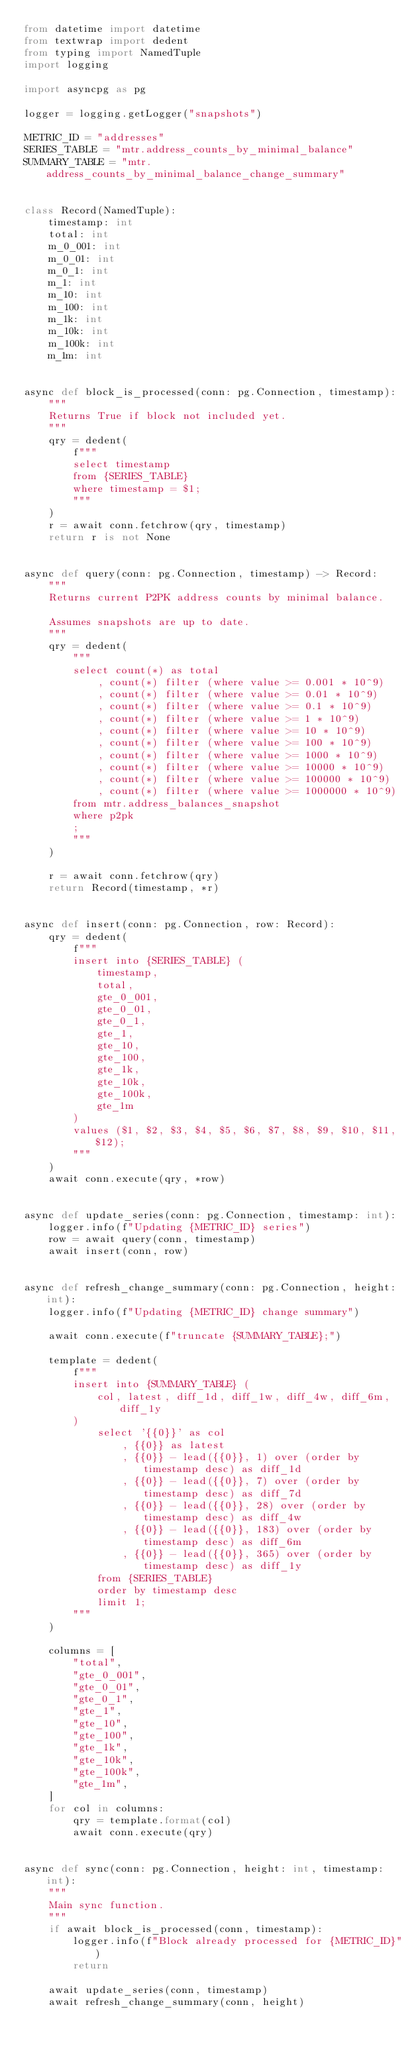Convert code to text. <code><loc_0><loc_0><loc_500><loc_500><_Python_>from datetime import datetime
from textwrap import dedent
from typing import NamedTuple
import logging

import asyncpg as pg

logger = logging.getLogger("snapshots")

METRIC_ID = "addresses"
SERIES_TABLE = "mtr.address_counts_by_minimal_balance"
SUMMARY_TABLE = "mtr.address_counts_by_minimal_balance_change_summary"


class Record(NamedTuple):
    timestamp: int
    total: int
    m_0_001: int
    m_0_01: int
    m_0_1: int
    m_1: int
    m_10: int
    m_100: int
    m_1k: int
    m_10k: int
    m_100k: int
    m_1m: int


async def block_is_processed(conn: pg.Connection, timestamp):
    """
    Returns True if block not included yet.
    """
    qry = dedent(
        f"""
        select timestamp
        from {SERIES_TABLE}
        where timestamp = $1;
        """
    )
    r = await conn.fetchrow(qry, timestamp)
    return r is not None


async def query(conn: pg.Connection, timestamp) -> Record:
    """
    Returns current P2PK address counts by minimal balance.

    Assumes snapshots are up to date.
    """
    qry = dedent(
        """
        select count(*) as total
            , count(*) filter (where value >= 0.001 * 10^9)
            , count(*) filter (where value >= 0.01 * 10^9)
            , count(*) filter (where value >= 0.1 * 10^9)
            , count(*) filter (where value >= 1 * 10^9)
            , count(*) filter (where value >= 10 * 10^9)
            , count(*) filter (where value >= 100 * 10^9)
            , count(*) filter (where value >= 1000 * 10^9)
            , count(*) filter (where value >= 10000 * 10^9)
            , count(*) filter (where value >= 100000 * 10^9)
            , count(*) filter (where value >= 1000000 * 10^9)
        from mtr.address_balances_snapshot
        where p2pk
        ;
        """
    )

    r = await conn.fetchrow(qry)
    return Record(timestamp, *r)


async def insert(conn: pg.Connection, row: Record):
    qry = dedent(
        f"""
        insert into {SERIES_TABLE} (
            timestamp,
            total,
            gte_0_001,
            gte_0_01,
            gte_0_1,
            gte_1,
            gte_10,
            gte_100,
            gte_1k,
            gte_10k,
            gte_100k,
            gte_1m
        )
        values ($1, $2, $3, $4, $5, $6, $7, $8, $9, $10, $11, $12);
        """
    )
    await conn.execute(qry, *row)


async def update_series(conn: pg.Connection, timestamp: int):
    logger.info(f"Updating {METRIC_ID} series")
    row = await query(conn, timestamp)
    await insert(conn, row)


async def refresh_change_summary(conn: pg.Connection, height: int):
    logger.info(f"Updating {METRIC_ID} change summary")

    await conn.execute(f"truncate {SUMMARY_TABLE};")

    template = dedent(
        f"""
        insert into {SUMMARY_TABLE} (
            col, latest, diff_1d, diff_1w, diff_4w, diff_6m, diff_1y
        )
            select '{{0}}' as col
                , {{0}} as latest
                , {{0}} - lead({{0}}, 1) over (order by timestamp desc) as diff_1d
                , {{0}} - lead({{0}}, 7) over (order by timestamp desc) as diff_7d
                , {{0}} - lead({{0}}, 28) over (order by timestamp desc) as diff_4w
                , {{0}} - lead({{0}}, 183) over (order by timestamp desc) as diff_6m
                , {{0}} - lead({{0}}, 365) over (order by timestamp desc) as diff_1y
            from {SERIES_TABLE}
            order by timestamp desc
            limit 1;
        """
    )

    columns = [
        "total",
        "gte_0_001",
        "gte_0_01",
        "gte_0_1",
        "gte_1",
        "gte_10",
        "gte_100",
        "gte_1k",
        "gte_10k",
        "gte_100k",
        "gte_1m",
    ]
    for col in columns:
        qry = template.format(col)
        await conn.execute(qry)


async def sync(conn: pg.Connection, height: int, timestamp: int):
    """
    Main sync function.
    """
    if await block_is_processed(conn, timestamp):
        logger.info(f"Block already processed for {METRIC_ID}")
        return

    await update_series(conn, timestamp)
    await refresh_change_summary(conn, height)
</code> 